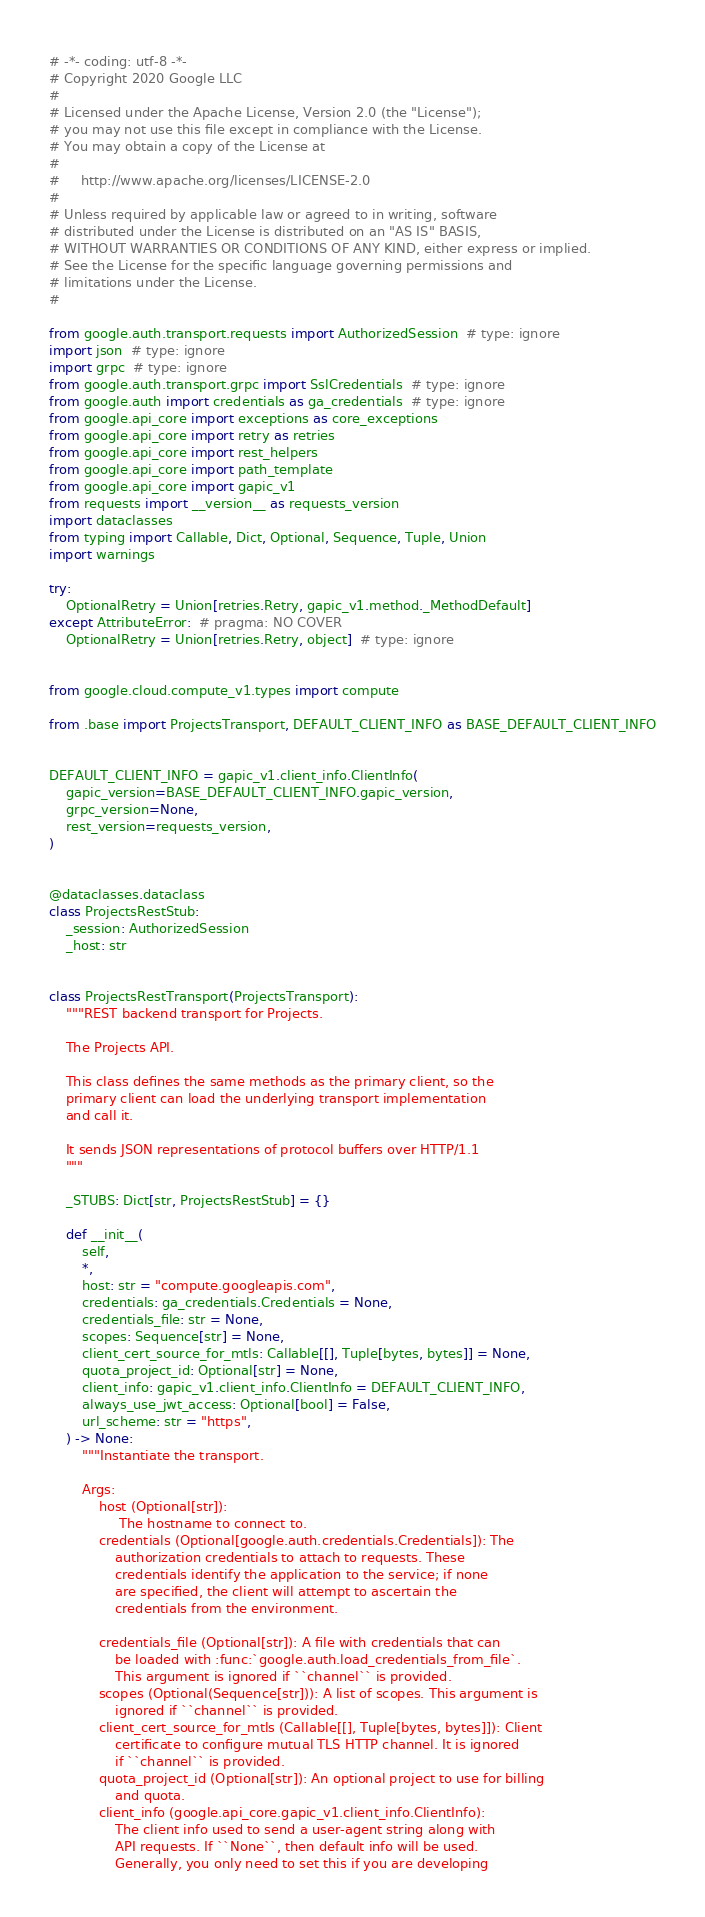Convert code to text. <code><loc_0><loc_0><loc_500><loc_500><_Python_># -*- coding: utf-8 -*-
# Copyright 2020 Google LLC
#
# Licensed under the Apache License, Version 2.0 (the "License");
# you may not use this file except in compliance with the License.
# You may obtain a copy of the License at
#
#     http://www.apache.org/licenses/LICENSE-2.0
#
# Unless required by applicable law or agreed to in writing, software
# distributed under the License is distributed on an "AS IS" BASIS,
# WITHOUT WARRANTIES OR CONDITIONS OF ANY KIND, either express or implied.
# See the License for the specific language governing permissions and
# limitations under the License.
#

from google.auth.transport.requests import AuthorizedSession  # type: ignore
import json  # type: ignore
import grpc  # type: ignore
from google.auth.transport.grpc import SslCredentials  # type: ignore
from google.auth import credentials as ga_credentials  # type: ignore
from google.api_core import exceptions as core_exceptions
from google.api_core import retry as retries
from google.api_core import rest_helpers
from google.api_core import path_template
from google.api_core import gapic_v1
from requests import __version__ as requests_version
import dataclasses
from typing import Callable, Dict, Optional, Sequence, Tuple, Union
import warnings

try:
    OptionalRetry = Union[retries.Retry, gapic_v1.method._MethodDefault]
except AttributeError:  # pragma: NO COVER
    OptionalRetry = Union[retries.Retry, object]  # type: ignore


from google.cloud.compute_v1.types import compute

from .base import ProjectsTransport, DEFAULT_CLIENT_INFO as BASE_DEFAULT_CLIENT_INFO


DEFAULT_CLIENT_INFO = gapic_v1.client_info.ClientInfo(
    gapic_version=BASE_DEFAULT_CLIENT_INFO.gapic_version,
    grpc_version=None,
    rest_version=requests_version,
)


@dataclasses.dataclass
class ProjectsRestStub:
    _session: AuthorizedSession
    _host: str


class ProjectsRestTransport(ProjectsTransport):
    """REST backend transport for Projects.

    The Projects API.

    This class defines the same methods as the primary client, so the
    primary client can load the underlying transport implementation
    and call it.

    It sends JSON representations of protocol buffers over HTTP/1.1
    """

    _STUBS: Dict[str, ProjectsRestStub] = {}

    def __init__(
        self,
        *,
        host: str = "compute.googleapis.com",
        credentials: ga_credentials.Credentials = None,
        credentials_file: str = None,
        scopes: Sequence[str] = None,
        client_cert_source_for_mtls: Callable[[], Tuple[bytes, bytes]] = None,
        quota_project_id: Optional[str] = None,
        client_info: gapic_v1.client_info.ClientInfo = DEFAULT_CLIENT_INFO,
        always_use_jwt_access: Optional[bool] = False,
        url_scheme: str = "https",
    ) -> None:
        """Instantiate the transport.

        Args:
            host (Optional[str]):
                 The hostname to connect to.
            credentials (Optional[google.auth.credentials.Credentials]): The
                authorization credentials to attach to requests. These
                credentials identify the application to the service; if none
                are specified, the client will attempt to ascertain the
                credentials from the environment.

            credentials_file (Optional[str]): A file with credentials that can
                be loaded with :func:`google.auth.load_credentials_from_file`.
                This argument is ignored if ``channel`` is provided.
            scopes (Optional(Sequence[str])): A list of scopes. This argument is
                ignored if ``channel`` is provided.
            client_cert_source_for_mtls (Callable[[], Tuple[bytes, bytes]]): Client
                certificate to configure mutual TLS HTTP channel. It is ignored
                if ``channel`` is provided.
            quota_project_id (Optional[str]): An optional project to use for billing
                and quota.
            client_info (google.api_core.gapic_v1.client_info.ClientInfo):
                The client info used to send a user-agent string along with
                API requests. If ``None``, then default info will be used.
                Generally, you only need to set this if you are developing</code> 